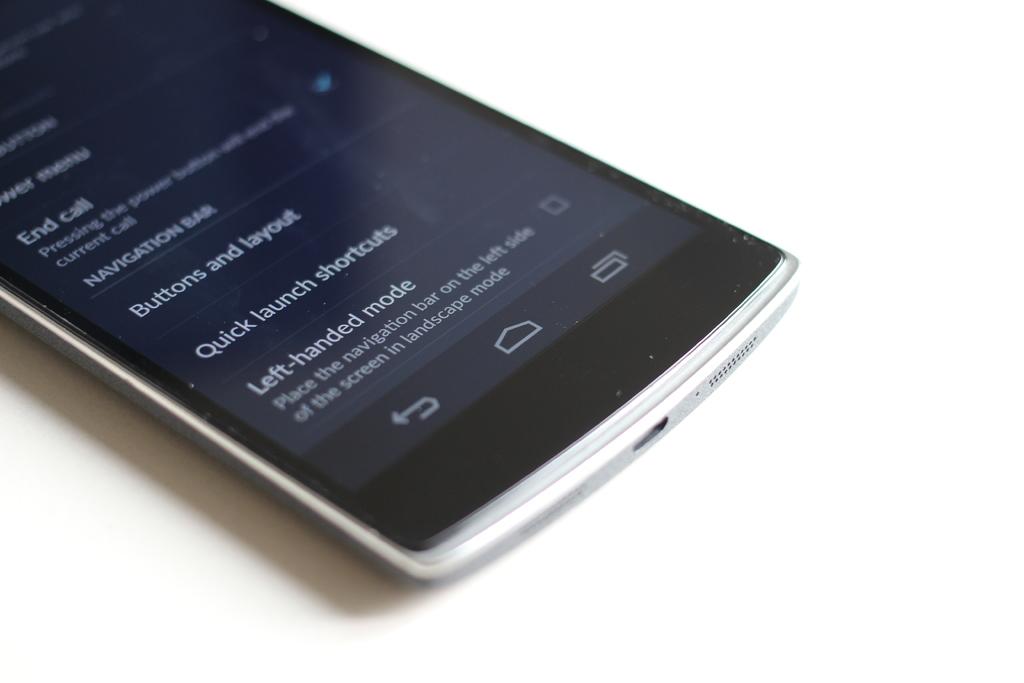What mode is this in?
Offer a terse response. Left handed mode. 